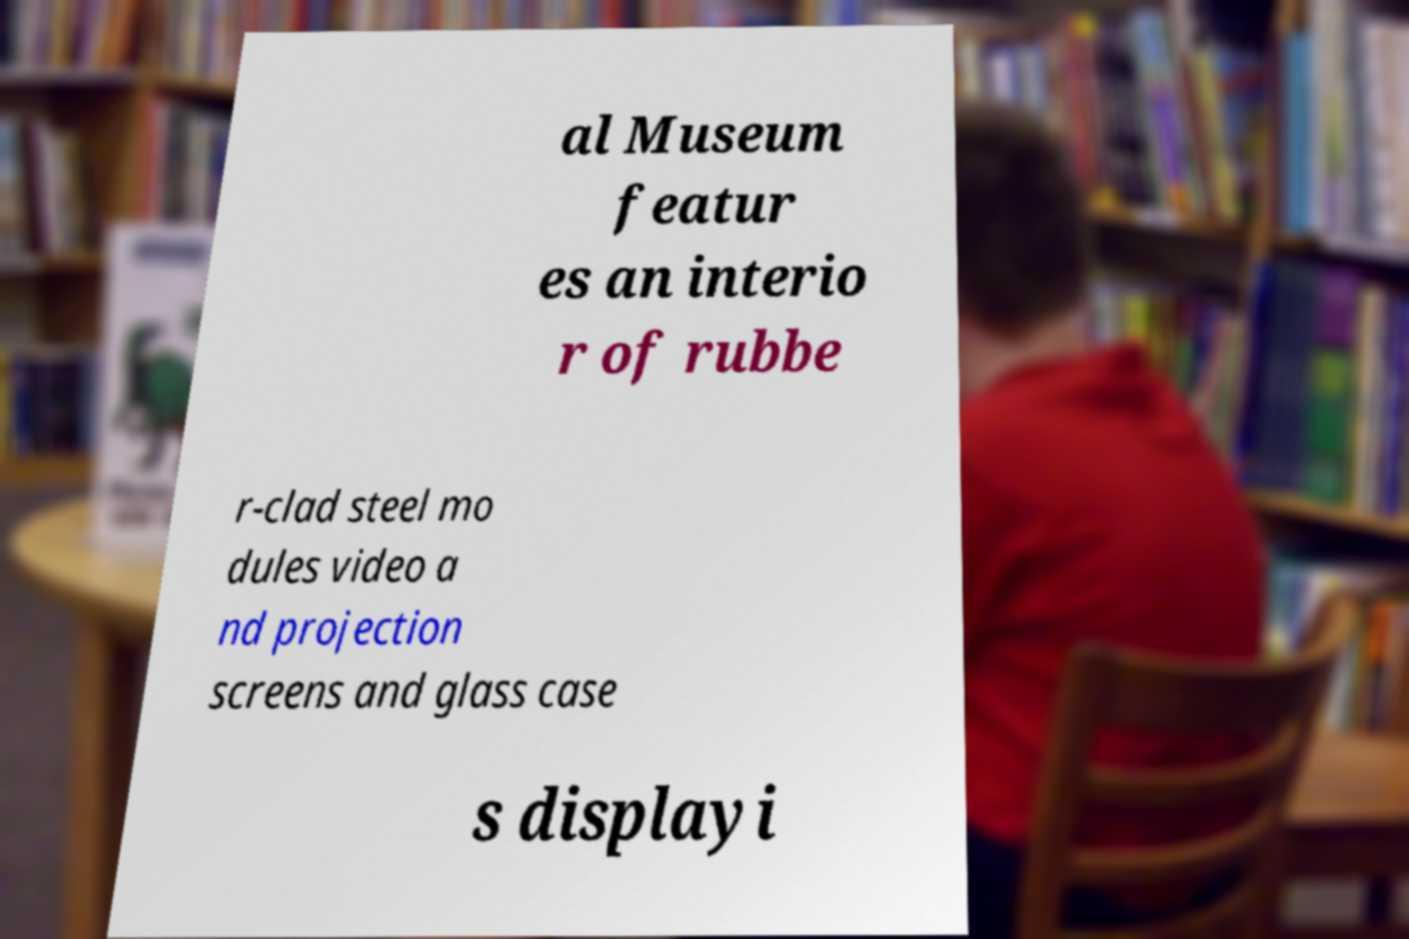Can you accurately transcribe the text from the provided image for me? al Museum featur es an interio r of rubbe r-clad steel mo dules video a nd projection screens and glass case s displayi 